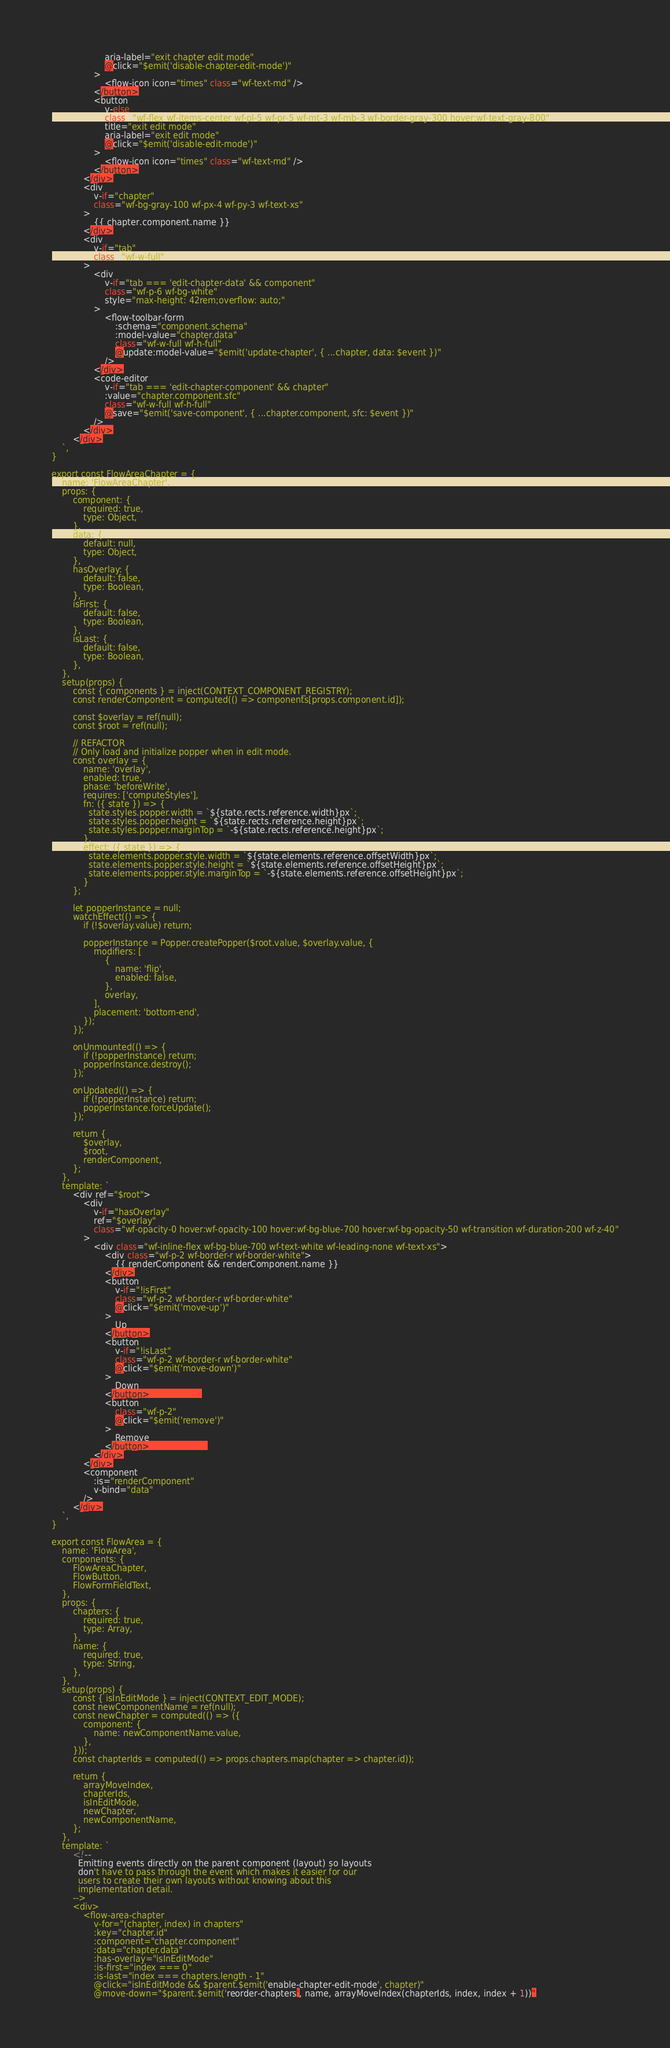Convert code to text. <code><loc_0><loc_0><loc_500><loc_500><_JavaScript_>                    aria-label="exit chapter edit mode"
                    @click="$emit('disable-chapter-edit-mode')"
                >
                    <flow-icon icon="times" class="wf-text-md" />
                </button>
                <button
                    v-else
                    class="wf-flex wf-items-center wf-pl-5 wf-pr-5 wf-mt-3 wf-mb-3 wf-border-gray-300 hover:wf-text-gray-800"
                    title="exit edit mode"
                    aria-label="exit edit mode"
                    @click="$emit('disable-edit-mode')"
                >
                    <flow-icon icon="times" class="wf-text-md" />
                </button>
            </div>
            <div
                v-if="chapter"
                class="wf-bg-gray-100 wf-px-4 wf-py-3 wf-text-xs"
            >
                {{ chapter.component.name }}
            </div>
            <div
                v-if="tab"
                class="wf-w-full"
            >
                <div
                    v-if="tab === 'edit-chapter-data' && component"
                    class="wf-p-6 wf-bg-white"
                    style="max-height: 42rem;overflow: auto;"
                >
                    <flow-toolbar-form
                        :schema="component.schema"
                        :model-value="chapter.data"
                        class="wf-w-full wf-h-full"
                        @update:model-value="$emit('update-chapter', { ...chapter, data: $event })"
                    />
                </div>
                <code-editor
                    v-if="tab === 'edit-chapter-component' && chapter"
                    :value="chapter.component.sfc"
                    class="wf-w-full wf-h-full"
                    @save="$emit('save-component', { ...chapter.component, sfc: $event })"
                />
            </div>
        </div>
    `,
}

export const FlowAreaChapter = {
    name: 'FlowAreaChapter',
    props: {
        component: {
            required: true,
            type: Object,
        },
        data: {
            default: null,
            type: Object,
        },
        hasOverlay: {
            default: false,
            type: Boolean,
        },
        isFirst: {
            default: false,
            type: Boolean,
        },
        isLast: {
            default: false,
            type: Boolean,
        },
    },
    setup(props) {
        const { components } = inject(CONTEXT_COMPONENT_REGISTRY);
        const renderComponent = computed(() => components[props.component.id]);

        const $overlay = ref(null);
        const $root = ref(null);

        // REFACTOR
        // Only load and initialize popper when in edit mode.
        const overlay = {
            name: 'overlay',
            enabled: true,
            phase: 'beforeWrite',
            requires: ['computeStyles'],
            fn: ({ state }) => {
              state.styles.popper.width = `${state.rects.reference.width}px`;
              state.styles.popper.height = `${state.rects.reference.height}px`;
              state.styles.popper.marginTop = `-${state.rects.reference.height}px`;
            },
            effect: ({ state }) => {
              state.elements.popper.style.width = `${state.elements.reference.offsetWidth}px`;
              state.elements.popper.style.height = `${state.elements.reference.offsetHeight}px`;
              state.elements.popper.style.marginTop = `-${state.elements.reference.offsetHeight}px`;
            }
        };

        let popperInstance = null;
        watchEffect(() => {
            if (!$overlay.value) return;

            popperInstance = Popper.createPopper($root.value, $overlay.value, {
                modifiers: [
                    {
                        name: 'flip',
                        enabled: false,
                    },
                    overlay,
                ],
                placement: 'bottom-end',
            });
        });

        onUnmounted(() => {
            if (!popperInstance) return;
            popperInstance.destroy();
        });

        onUpdated(() => {
            if (!popperInstance) return;
            popperInstance.forceUpdate();
        });

        return {
            $overlay,
            $root,
            renderComponent,
        };
    },
    template: `
        <div ref="$root">
            <div
                v-if="hasOverlay"
                ref="$overlay"
                class="wf-opacity-0 hover:wf-opacity-100 hover:wf-bg-blue-700 hover:wf-bg-opacity-50 wf-transition wf-duration-200 wf-z-40"
            >
                <div class="wf-inline-flex wf-bg-blue-700 wf-text-white wf-leading-none wf-text-xs">
                    <div class="wf-p-2 wf-border-r wf-border-white">
                        {{ renderComponent && renderComponent.name }}
                    </div>
                    <button
                        v-if="!isFirst"
                        class="wf-p-2 wf-border-r wf-border-white"
                        @click="$emit('move-up')"
                    >
                        Up
                    </button>
                    <button
                        v-if="!isLast"
                        class="wf-p-2 wf-border-r wf-border-white"
                        @click="$emit('move-down')"
                    >
                        Down
                    </button>                  
                    <button                       
                        class="wf-p-2"
                        @click="$emit('remove')"
                    >
                        Remove
                    </button>                    
                </div>
            </div>
            <component
                :is="renderComponent"
                v-bind="data"
            />
        </div>
    `,
}

export const FlowArea = {
    name: 'FlowArea',
    components: {
        FlowAreaChapter,
        FlowButton,
        FlowFormFieldText,
    },
    props: {
        chapters: {
            required: true,
            type: Array,
        },
        name: {
            required: true,
            type: String,
        },
    },
    setup(props) {
        const { isInEditMode } = inject(CONTEXT_EDIT_MODE);
        const newComponentName = ref(null);
        const newChapter = computed(() => ({
            component: {
                name: newComponentName.value,
            },
        }));
        const chapterIds = computed(() => props.chapters.map(chapter => chapter.id));

        return {
            arrayMoveIndex,
            chapterIds,
            isInEditMode,
            newChapter,
            newComponentName,
        };
    },
    template: `
        <!--
          Emitting events directly on the parent component (layout) so layouts
          don't have to pass through the event which makes it easier for our
          users to create their own layouts without knowing about this
          implementation detail.
        -->
        <div>
            <flow-area-chapter
                v-for="(chapter, index) in chapters"
                :key="chapter.id"
                :component="chapter.component"
                :data="chapter.data"
                :has-overlay="isInEditMode"
                :is-first="index === 0"
                :is-last="index === chapters.length - 1"
                @click="isInEditMode && $parent.$emit('enable-chapter-edit-mode', chapter)"
                @move-down="$parent.$emit('reorder-chapters', name, arrayMoveIndex(chapterIds, index, index + 1))"</code> 